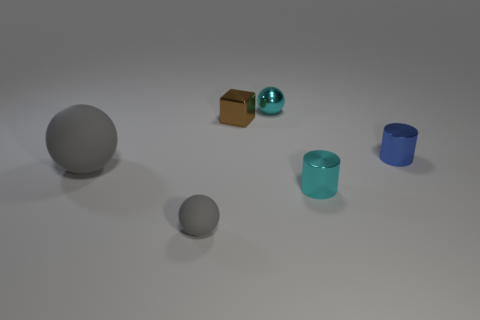Could you relate the shapes and colors of these objects to a particular season or natural environment? Certainly! The cool blue tones and the icy appearance of the cylinders might evoke a wintery scene, one that's tranquil and crisp. In contrast, the brown cube can be reminiscent of the earth during autumn, a symbol of transition and change. Likewise, the shiny cyan ball echoes the vibrancy of a clear, refreshing summer sky. 